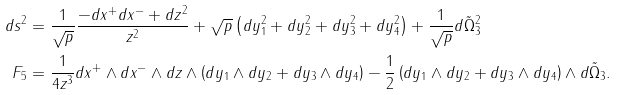<formula> <loc_0><loc_0><loc_500><loc_500>d s ^ { 2 } & = \frac { 1 } { \sqrt { p } } \frac { - d x ^ { + } d x ^ { - } + d z ^ { 2 } } { z ^ { 2 } } + \sqrt { p } \left ( d y _ { 1 } ^ { 2 } + d y _ { 2 } ^ { 2 } + d y _ { 3 } ^ { 2 } + d y _ { 4 } ^ { 2 } \right ) + \frac { 1 } { \sqrt { p } } d \tilde { \Omega } _ { 3 } ^ { 2 } \\ F _ { 5 } & = \frac { 1 } { 4 z ^ { 3 } } d x ^ { + } \wedge d x ^ { - } \wedge d z \wedge \left ( d y _ { 1 } \wedge d y _ { 2 } + d y _ { 3 } \wedge d y _ { 4 } \right ) - \frac { 1 } { 2 } \left ( d y _ { 1 } \wedge d y _ { 2 } + d y _ { 3 } \wedge d y _ { 4 } \right ) \wedge d \tilde { \Omega } _ { 3 } .</formula> 